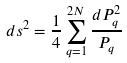Convert formula to latex. <formula><loc_0><loc_0><loc_500><loc_500>d s ^ { 2 } = \frac { 1 } { 4 } \sum _ { q = 1 } ^ { 2 N } \frac { d P _ { q } ^ { 2 } } { P _ { q } }</formula> 